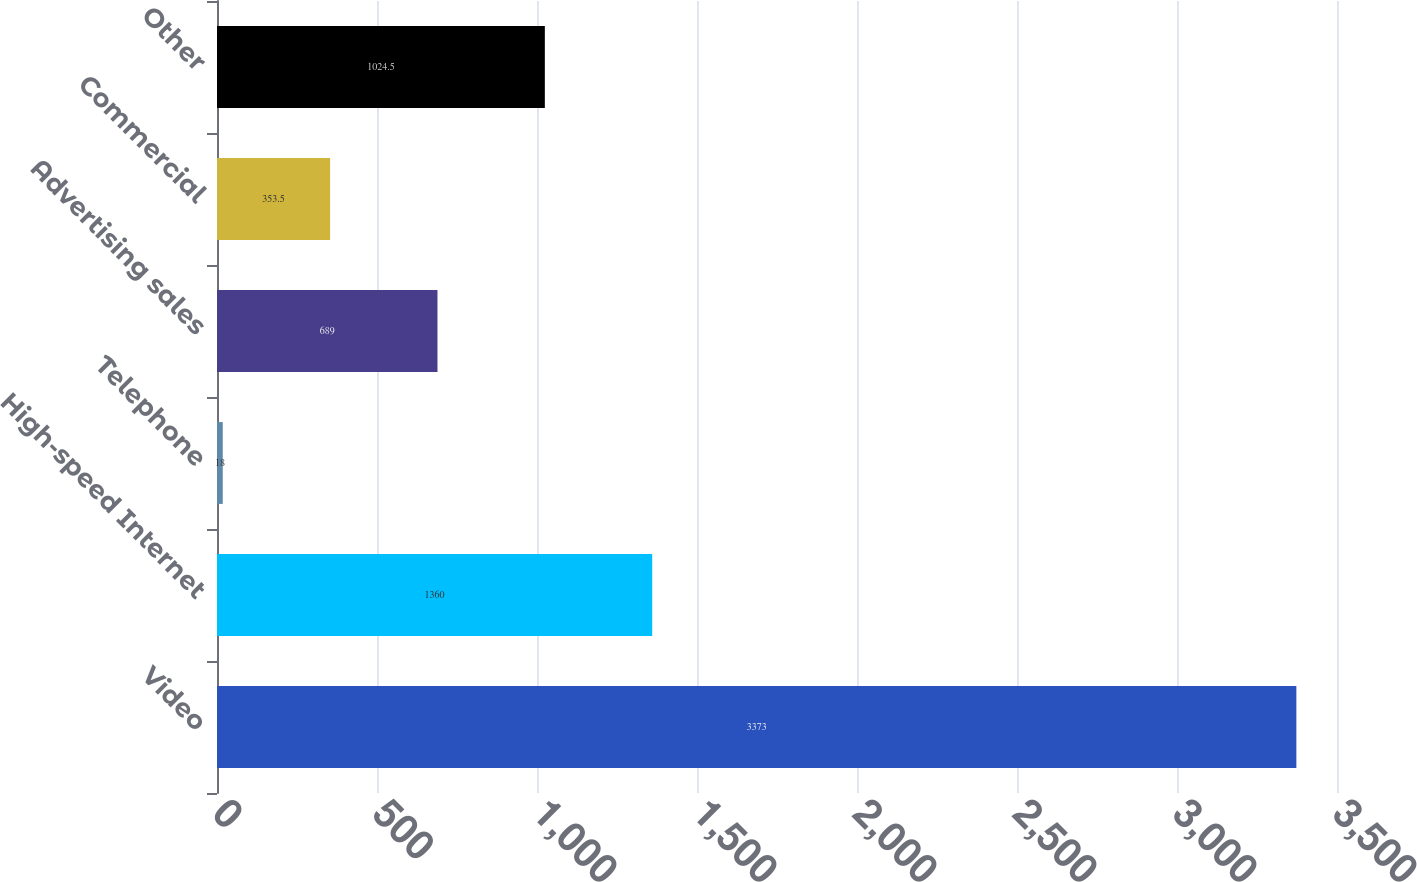Convert chart to OTSL. <chart><loc_0><loc_0><loc_500><loc_500><bar_chart><fcel>Video<fcel>High-speed Internet<fcel>Telephone<fcel>Advertising sales<fcel>Commercial<fcel>Other<nl><fcel>3373<fcel>1360<fcel>18<fcel>689<fcel>353.5<fcel>1024.5<nl></chart> 